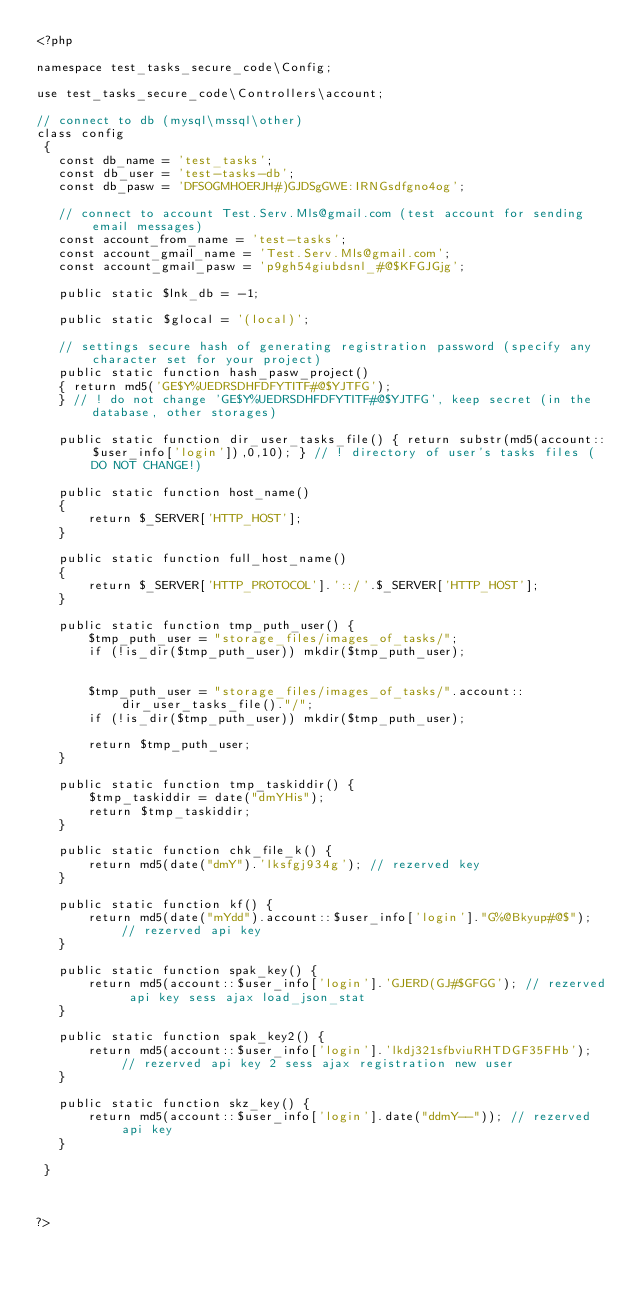<code> <loc_0><loc_0><loc_500><loc_500><_PHP_><?php
 
namespace test_tasks_secure_code\Config;

use test_tasks_secure_code\Controllers\account;

// connect to db (mysql\mssql\other)
class config
 {
   const db_name = 'test_tasks';
   const db_user = 'test-tasks-db';
   const db_pasw = 'DFSOGMHOERJH#)GJDSgGWE:IRNGsdfgno4og';

   // connect to account Test.Serv.Mls@gmail.com (test account for sending email messages)
   const account_from_name = 'test-tasks';
   const account_gmail_name = 'Test.Serv.Mls@gmail.com';
   const account_gmail_pasw = 'p9gh54giubdsnl_#@$KFGJGjg';

   public static $lnk_db = -1;

   public static $glocal = '(local)';

   // settings secure hash of generating registration password (specify any character set for your project)
   public static function hash_pasw_project() 
   { return md5('GE$Y%UEDRSDHFDFYTITF#@$YJTFG'); 
   } // ! do not change 'GE$Y%UEDRSDHFDFYTITF#@$YJTFG', keep secret (in the database, other storages)

   public static function dir_user_tasks_file() { return substr(md5(account::$user_info['login']),0,10); } // ! directory of user's tasks files (DO NOT CHANGE!)
 
   public static function host_name()
   {
       return $_SERVER['HTTP_HOST'];
   }

   public static function full_host_name()
   {
       return $_SERVER['HTTP_PROTOCOL'].'::/'.$_SERVER['HTTP_HOST'];
   }

   public static function tmp_puth_user() { 
       $tmp_puth_user = "storage_files/images_of_tasks/";
       if (!is_dir($tmp_puth_user)) mkdir($tmp_puth_user);

           
       $tmp_puth_user = "storage_files/images_of_tasks/".account::dir_user_tasks_file()."/";
       if (!is_dir($tmp_puth_user)) mkdir($tmp_puth_user);

       return $tmp_puth_user;
   }
   
   public static function tmp_taskiddir() { 
       $tmp_taskiddir = date("dmYHis");
       return $tmp_taskiddir;
   }
   
   public static function chk_file_k() { 
       return md5(date("dmY").'lksfgj934g'); // rezerved key
   }

   public static function kf() { 
       return md5(date("mYdd").account::$user_info['login']."G%@Bkyup#@$"); // rezerved api key
   }
   
   public static function spak_key() { 
       return md5(account::$user_info['login'].'GJERD(GJ#$GFGG'); // rezerved api key sess ajax load_json_stat
   }
   
   public static function spak_key2() { 
       return md5(account::$user_info['login'].'lkdj321sfbviuRHTDGF35FHb'); // rezerved api key 2 sess ajax registration new user  
   }

   public static function skz_key() { 
       return md5(account::$user_info['login'].date("ddmY--")); // rezerved api key
   }

 }

 
    
?></code> 